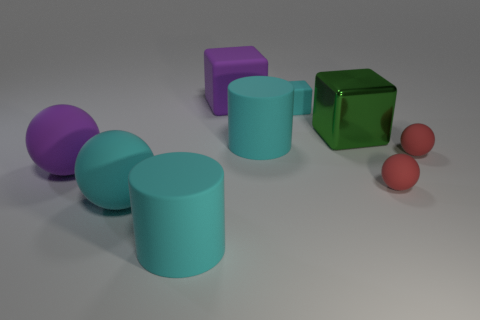What colors are present in the image, and how many objects share the same color? The colors present in the image include purple, cyan, green, and red. Each color is unique to its respective object, so there are no repetitions of color among multiple objects. 